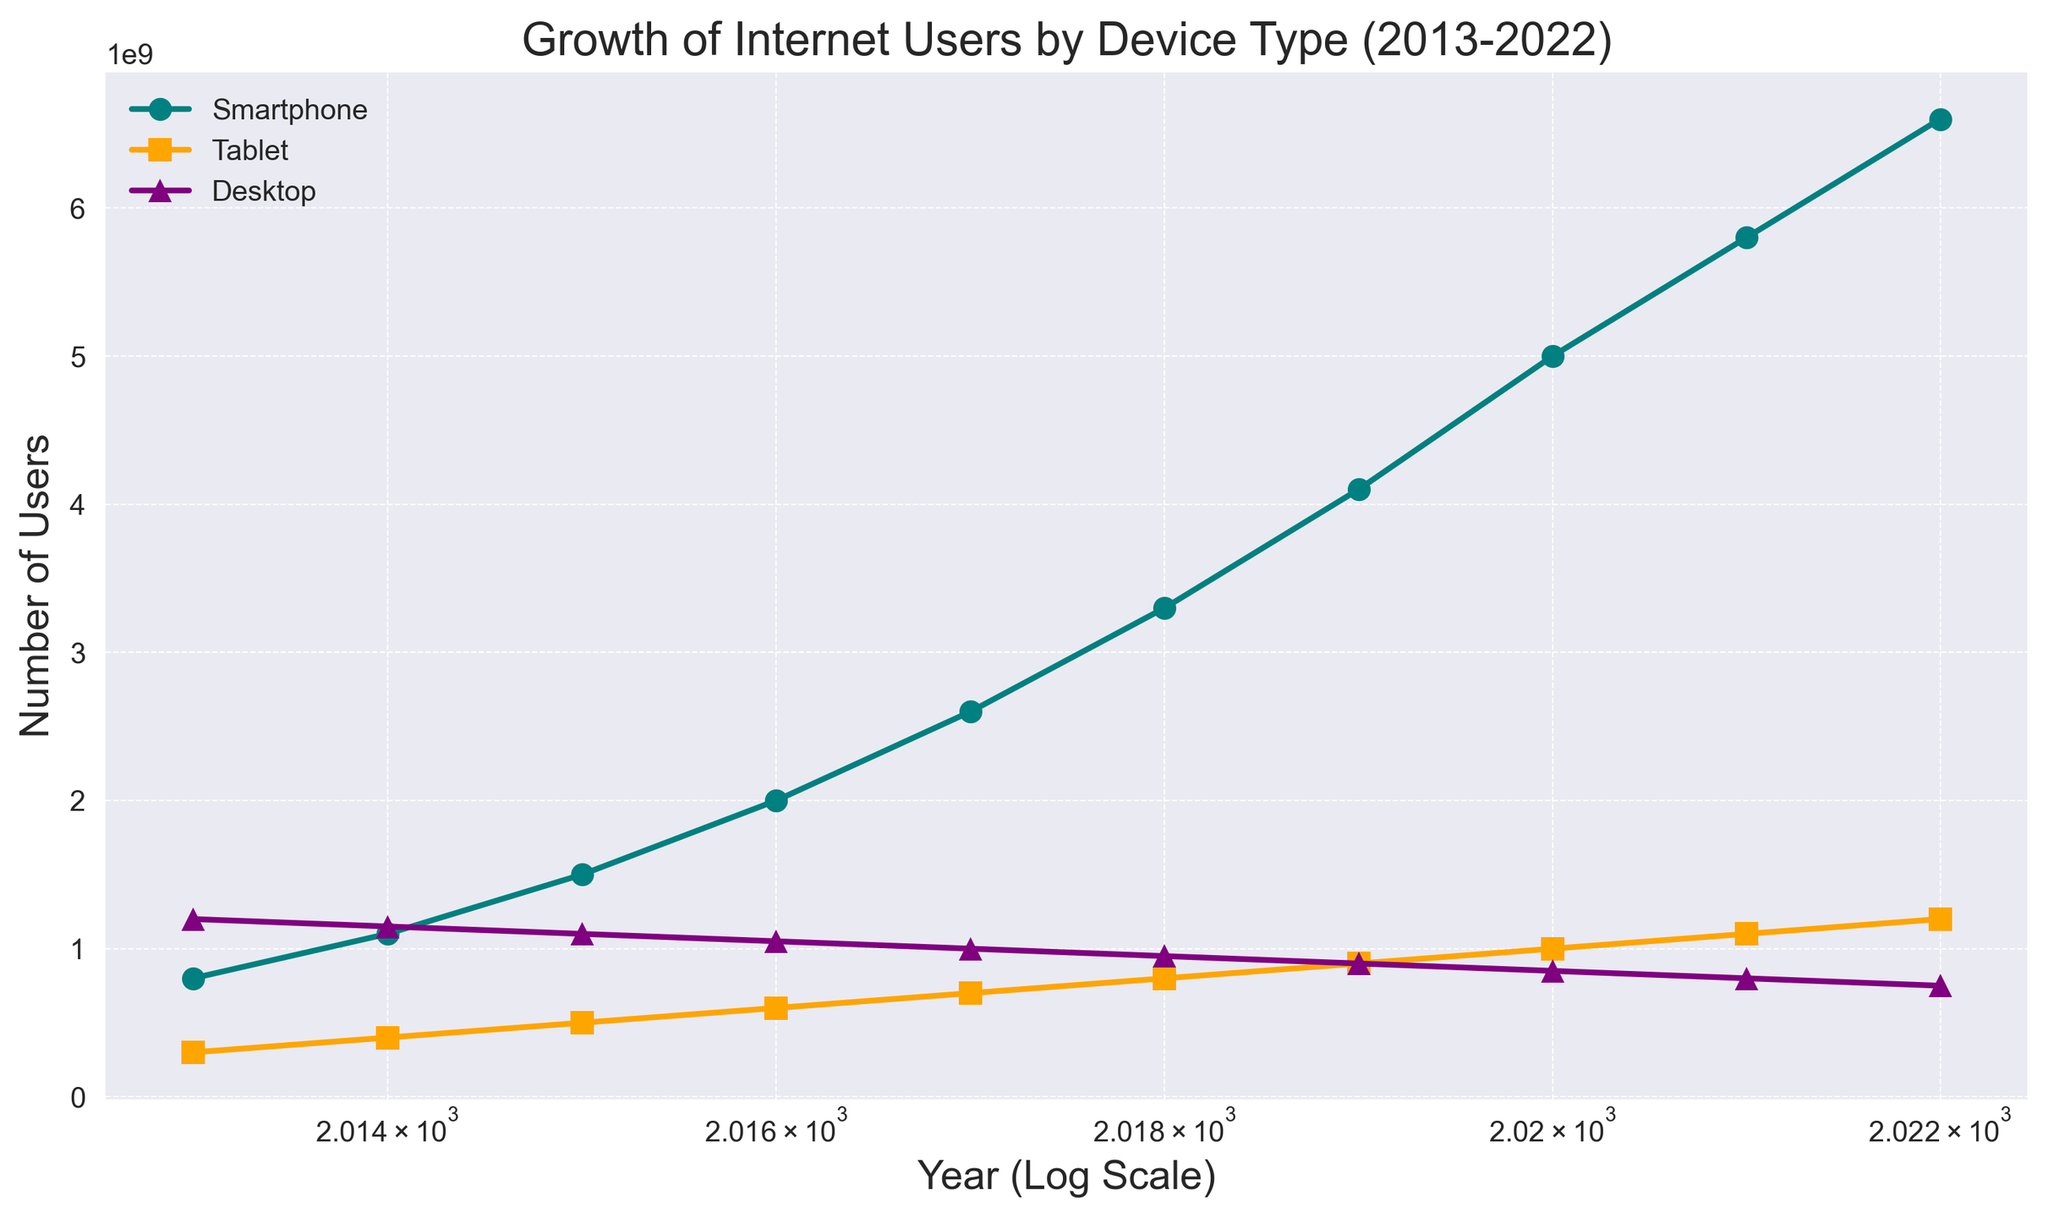What trends can you observe in the growth of smartphone users compared to desktop users over the last decade? The data shows a steady increase in smartphone users from 800 million in 2013 to 6.6 billion in 2022, while desktop users decreased from 1.2 billion to 750 million in the same period. This indicates a rapid growth of smartphone users and a decline in desktop users.
Answer: Smartphone users increased; desktop users decreased Which year saw the largest increase in smartphone users? The jump from 4.1 billion users in 2019 to 5 billion users in 2020 represents a 900 million user increase, which is the largest annual increase over the period.
Answer: 2020 How do the number of tablet users in 2016 compare to the number of desktop users in the same year? In 2016, there were 600 million tablet users and 1.05 billion desktop users. Desktop users were more than tablet users by 450 million.
Answer: Desktop users were more What's the average number of smartphone users from 2013 to 2018? Sum the number of smartphone users from 2013 to 2018 (800M + 1.1B + 1.5B + 2B + 2.6B + 3.3B) and divide by 6 years: (800M + 1100M + 1500M + 2000M + 2600M + 3300M) / 6 = 11300M/6 ≈ 1.883 billion.
Answer: Approximately 1.883 billion What was the trend for the number of users of each device type between 2016 and 2017? For smartphones, users increased from 2 billion to 2.6 billion, tablets increased from 600 million to 700 million, and desktops decreased from 1.05 billion to 1 billion.
Answer: Smartphones and tablets increased; desktops decreased What is the ratio of smartphone users to tablet users in 2021? In 2021, there were 5.8 billion smartphone users and 1.1 billion tablet users. The ratio is 5.8 billion / 1.1 billion = 5.27.
Answer: 5.27 Which device had the least growth in users from 2013 to 2022? The desktop user count decreased from 1.2 billion in 2013 to 750 million in 2022, indicating negative growth. Tablets increased from 300 million to 1.2 billion, and smartphones significantly increased.
Answer: Desktop What significant change can be visually observed in the color-coded lines for each device between 2013 and 2022? The teal line representing smartphones shows a consistent and significant upward trend, the orange line for tablets shows an increase albeit at a slower rate, and the purple line for desktops shows a downward trend. The magnitude and direction of these lines are clearly visible and indicative of the growth pattern.
Answer: Smartphones increased, tablets slightly increased, desktops decreased 